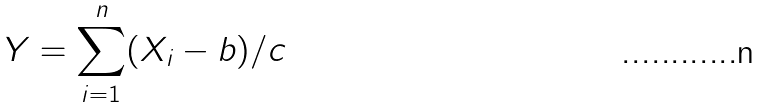<formula> <loc_0><loc_0><loc_500><loc_500>Y = \sum _ { i = 1 } ^ { n } ( X _ { i } - b ) / c</formula> 